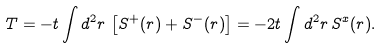<formula> <loc_0><loc_0><loc_500><loc_500>T = - t \int d ^ { 2 } r \, \left [ S ^ { + } ( { r } ) + S ^ { - } ( { r } ) \right ] = - 2 t \int d ^ { 2 } r \, S ^ { x } ( { r } ) .</formula> 